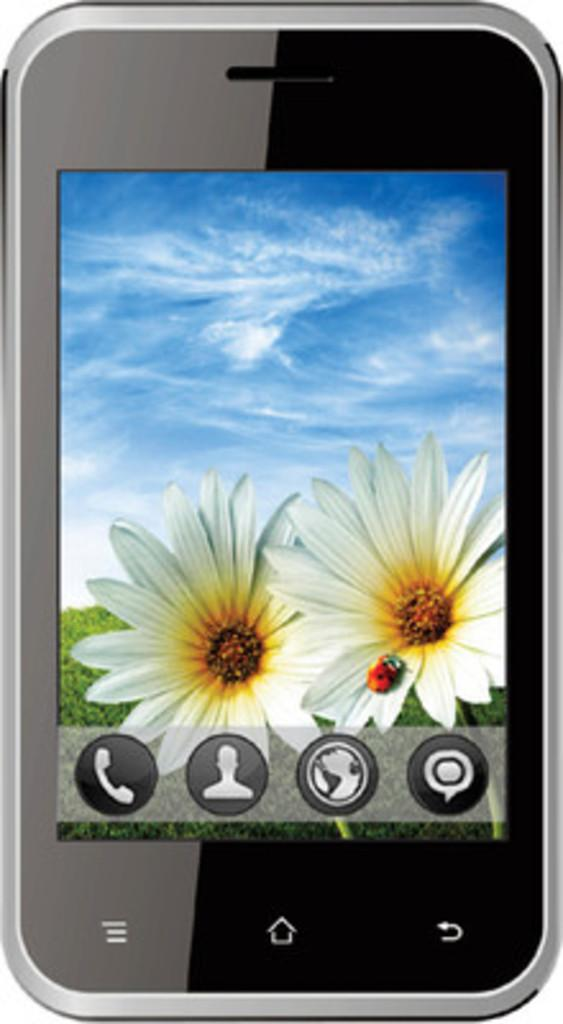What object is the main subject of the image? There is a mobile in the image. What can be seen on the mobile's screen? The mobile's screen displays icons, flowers, and the sky. Can you see a snake slithering across the mobile's screen in the image? No, there is no snake present on the mobile's screen in the image. 